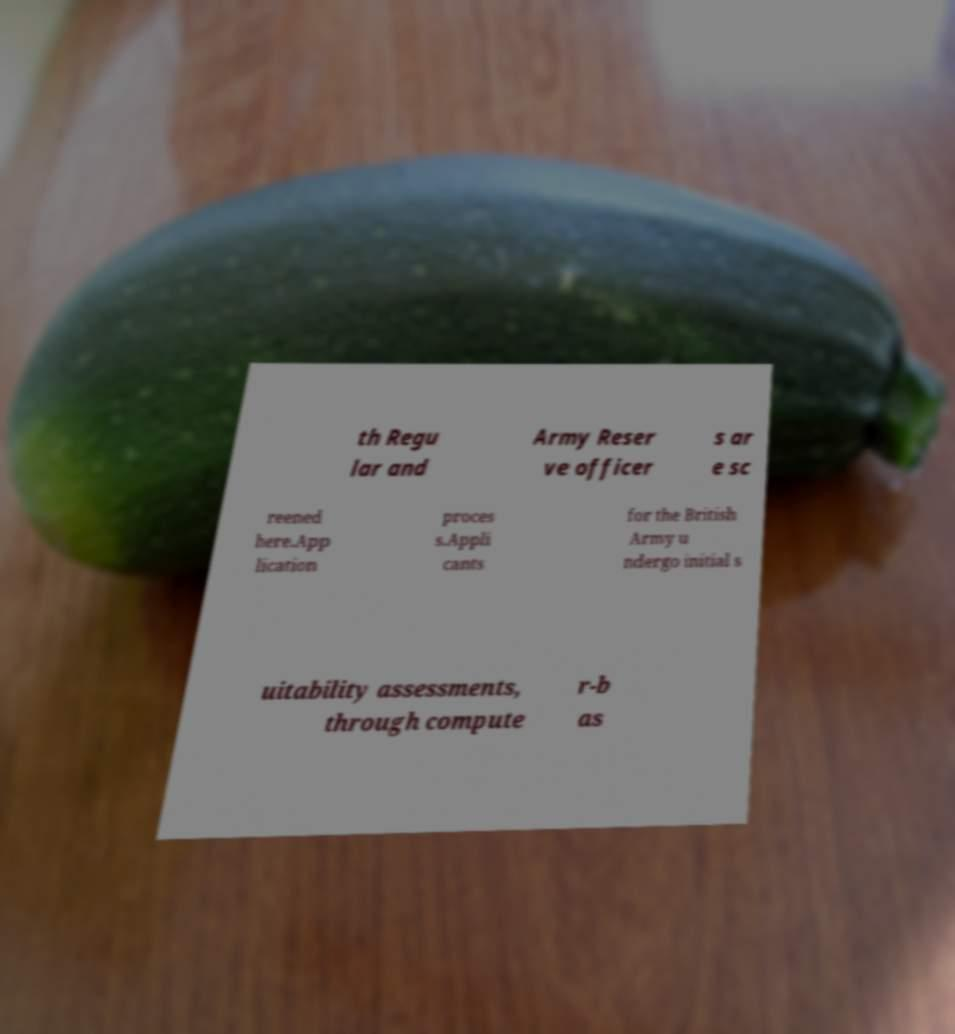What messages or text are displayed in this image? I need them in a readable, typed format. th Regu lar and Army Reser ve officer s ar e sc reened here.App lication proces s.Appli cants for the British Army u ndergo initial s uitability assessments, through compute r-b as 